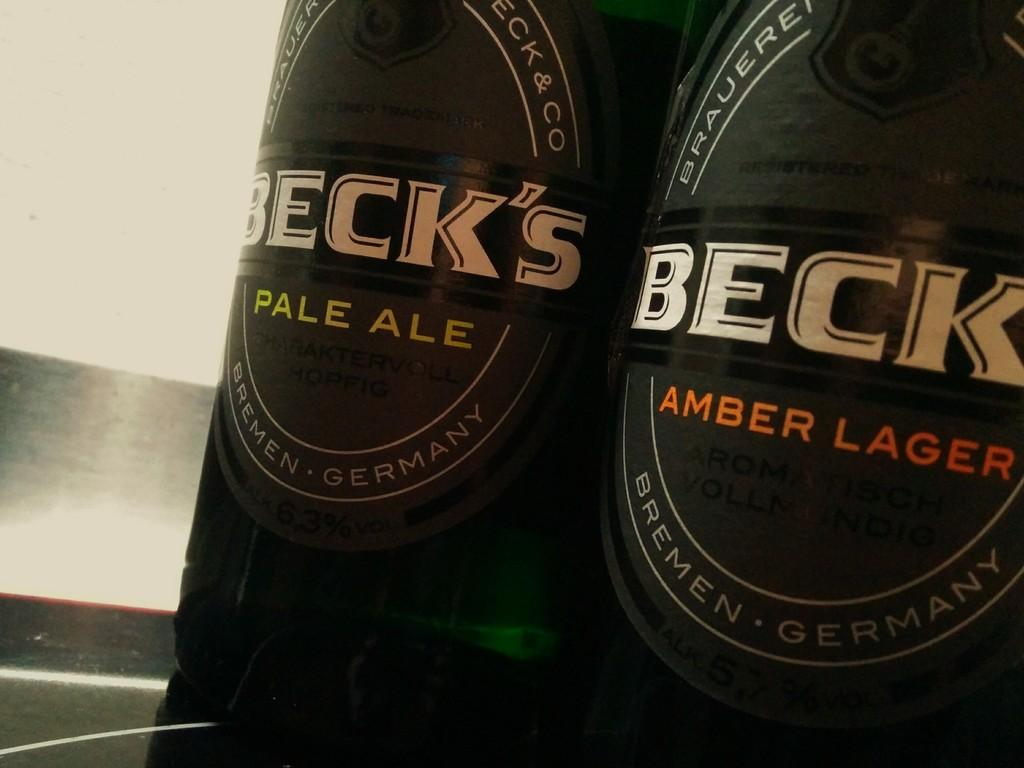How many bottles are visible in the image? There are two bottles in the image. What is on the bottles in the image? Stickers are pasted on the bottles. What type of pies are being served by the lawyer in the image? There is no lawyer or pies present in the image; it only features two bottles with stickers on them. 